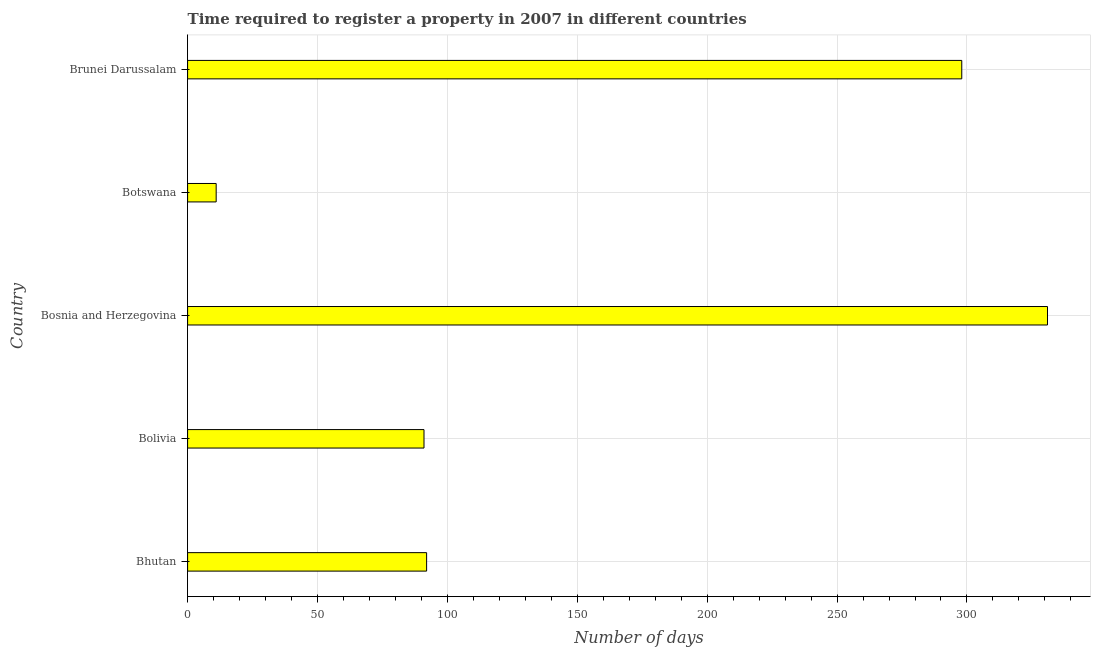Does the graph contain any zero values?
Offer a terse response. No. What is the title of the graph?
Give a very brief answer. Time required to register a property in 2007 in different countries. What is the label or title of the X-axis?
Offer a very short reply. Number of days. What is the label or title of the Y-axis?
Offer a terse response. Country. What is the number of days required to register property in Bhutan?
Offer a terse response. 92. Across all countries, what is the maximum number of days required to register property?
Provide a short and direct response. 331. Across all countries, what is the minimum number of days required to register property?
Keep it short and to the point. 11. In which country was the number of days required to register property maximum?
Provide a short and direct response. Bosnia and Herzegovina. In which country was the number of days required to register property minimum?
Provide a succinct answer. Botswana. What is the sum of the number of days required to register property?
Your response must be concise. 823. What is the difference between the number of days required to register property in Bosnia and Herzegovina and Botswana?
Offer a terse response. 320. What is the average number of days required to register property per country?
Offer a terse response. 164.6. What is the median number of days required to register property?
Make the answer very short. 92. What is the ratio of the number of days required to register property in Botswana to that in Brunei Darussalam?
Your response must be concise. 0.04. Is the number of days required to register property in Bolivia less than that in Bosnia and Herzegovina?
Your response must be concise. Yes. Is the difference between the number of days required to register property in Botswana and Brunei Darussalam greater than the difference between any two countries?
Make the answer very short. No. What is the difference between the highest and the lowest number of days required to register property?
Offer a very short reply. 320. In how many countries, is the number of days required to register property greater than the average number of days required to register property taken over all countries?
Give a very brief answer. 2. What is the difference between two consecutive major ticks on the X-axis?
Ensure brevity in your answer.  50. Are the values on the major ticks of X-axis written in scientific E-notation?
Offer a terse response. No. What is the Number of days in Bhutan?
Keep it short and to the point. 92. What is the Number of days in Bolivia?
Your response must be concise. 91. What is the Number of days in Bosnia and Herzegovina?
Make the answer very short. 331. What is the Number of days in Brunei Darussalam?
Your answer should be very brief. 298. What is the difference between the Number of days in Bhutan and Bosnia and Herzegovina?
Provide a succinct answer. -239. What is the difference between the Number of days in Bhutan and Brunei Darussalam?
Provide a short and direct response. -206. What is the difference between the Number of days in Bolivia and Bosnia and Herzegovina?
Keep it short and to the point. -240. What is the difference between the Number of days in Bolivia and Botswana?
Ensure brevity in your answer.  80. What is the difference between the Number of days in Bolivia and Brunei Darussalam?
Offer a very short reply. -207. What is the difference between the Number of days in Bosnia and Herzegovina and Botswana?
Provide a short and direct response. 320. What is the difference between the Number of days in Bosnia and Herzegovina and Brunei Darussalam?
Keep it short and to the point. 33. What is the difference between the Number of days in Botswana and Brunei Darussalam?
Give a very brief answer. -287. What is the ratio of the Number of days in Bhutan to that in Bolivia?
Provide a succinct answer. 1.01. What is the ratio of the Number of days in Bhutan to that in Bosnia and Herzegovina?
Provide a succinct answer. 0.28. What is the ratio of the Number of days in Bhutan to that in Botswana?
Make the answer very short. 8.36. What is the ratio of the Number of days in Bhutan to that in Brunei Darussalam?
Your response must be concise. 0.31. What is the ratio of the Number of days in Bolivia to that in Bosnia and Herzegovina?
Make the answer very short. 0.28. What is the ratio of the Number of days in Bolivia to that in Botswana?
Give a very brief answer. 8.27. What is the ratio of the Number of days in Bolivia to that in Brunei Darussalam?
Ensure brevity in your answer.  0.3. What is the ratio of the Number of days in Bosnia and Herzegovina to that in Botswana?
Offer a very short reply. 30.09. What is the ratio of the Number of days in Bosnia and Herzegovina to that in Brunei Darussalam?
Keep it short and to the point. 1.11. What is the ratio of the Number of days in Botswana to that in Brunei Darussalam?
Provide a short and direct response. 0.04. 